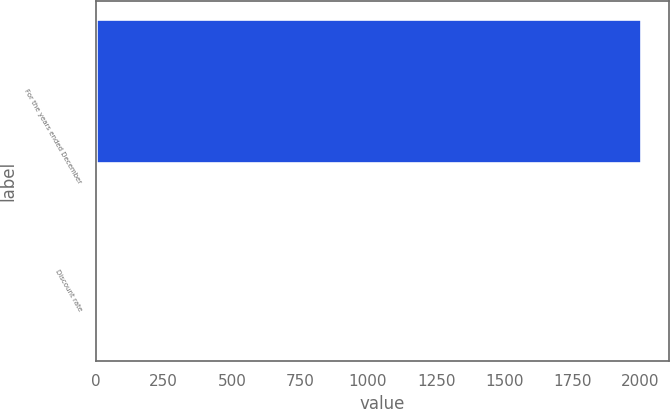Convert chart. <chart><loc_0><loc_0><loc_500><loc_500><bar_chart><fcel>For the years ended December<fcel>Discount rate<nl><fcel>2004<fcel>6<nl></chart> 